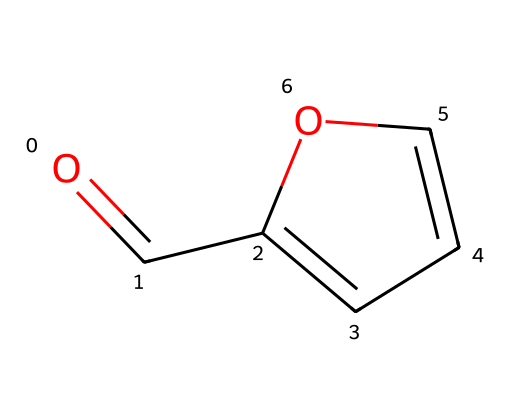what is the molecular formula of furfural? By analyzing the SMILES representation, we can deduce the atoms present. The structure includes five carbon atoms (C), four hydrogen atoms (H), and one oxygen atom (O), which leads to the molecular formula C5H4O.
Answer: C5H4O how many rings are present in the structure? The SMILES indicates a cyclic structure (noted by the "C1" and "C=CO" patterns), which forms a single ring. Therefore, there is one ring in the structure.
Answer: one what type of functional group is present in furfural? The structure contains a carbonyl group (C=O) bonded to a CH group, characteristic of aldehydes. This identifies the chemical as having an aldehyde functional group.
Answer: aldehyde how many double bonds are in the chemical structure? Examining the structure, we observe one C=O double bond and another C=C double bond. Therefore, there are a total of two double bonds in the chemical.
Answer: two how many hydrogens are attached to the carbonyl carbon? The carbonyl carbon in aldehydes is bonded to one hydrogen atom directly, which can be seen from the structure where the aldehyde group (C=O) has one hydrogen (the 'H' immediately connected to the carbon that is double bonded to O).
Answer: one what type of reaction might furfural primarily undergo due to its functional group? Aldehydes, including furfural, commonly undergo oxidation reactions where they can be converted into carboxylic acids. This transformation is due to the reactive nature of the carbonyl group.
Answer: oxidation 